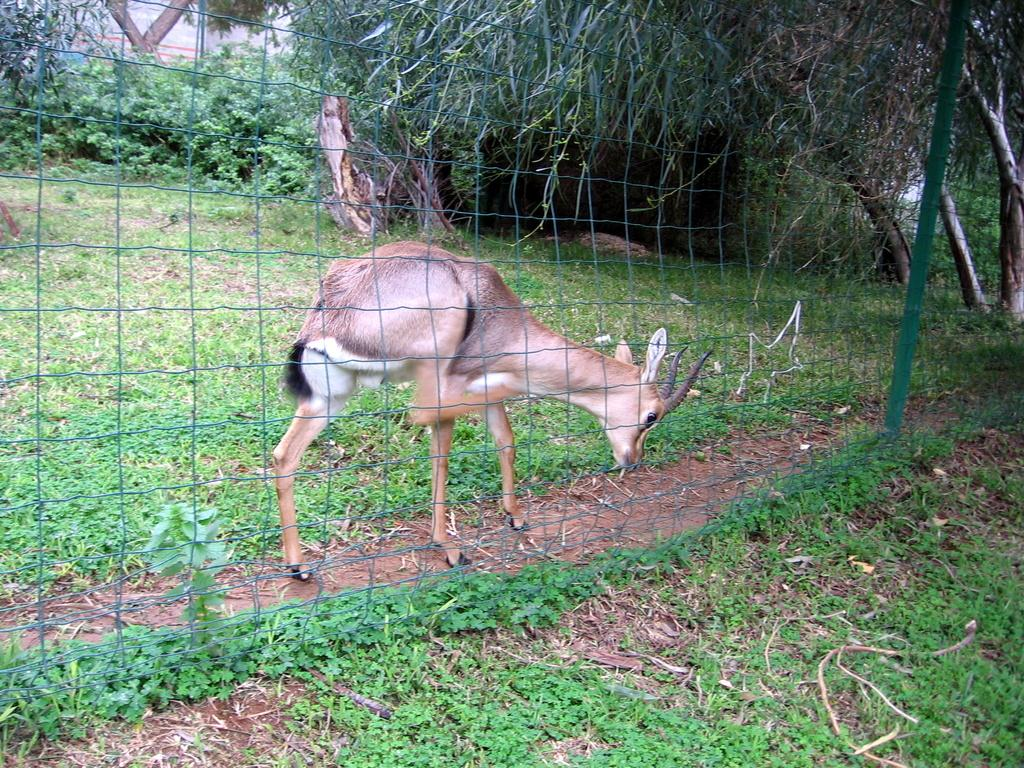What type of living organisms can be seen in the image? Plants and an animal are visible in the image. What is the mesh used for in the image? The mesh is used to separate or enclose the animal in the image. What type of vegetation is visible in the image? Trees are visible in the image. What type of bottle is visible in the image? There is no bottle present in the image. 